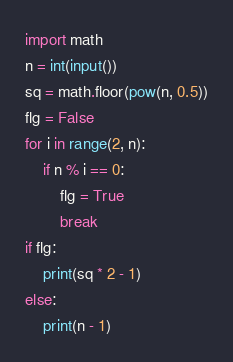<code> <loc_0><loc_0><loc_500><loc_500><_Python_>import math
n = int(input())
sq = math.floor(pow(n, 0.5))
flg = False
for i in range(2, n):
    if n % i == 0:
        flg = True
        break
if flg:
    print(sq * 2 - 1)
else:
    print(n - 1)
</code> 